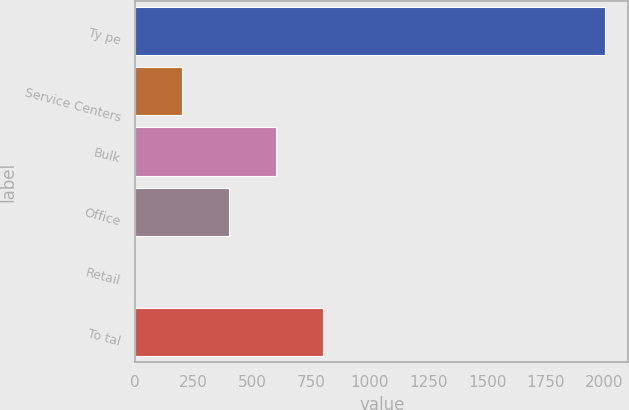Convert chart to OTSL. <chart><loc_0><loc_0><loc_500><loc_500><bar_chart><fcel>Ty pe<fcel>Service Centers<fcel>Bulk<fcel>Office<fcel>Retail<fcel>To tal<nl><fcel>2002<fcel>200.92<fcel>601.16<fcel>401.04<fcel>0.8<fcel>801.28<nl></chart> 